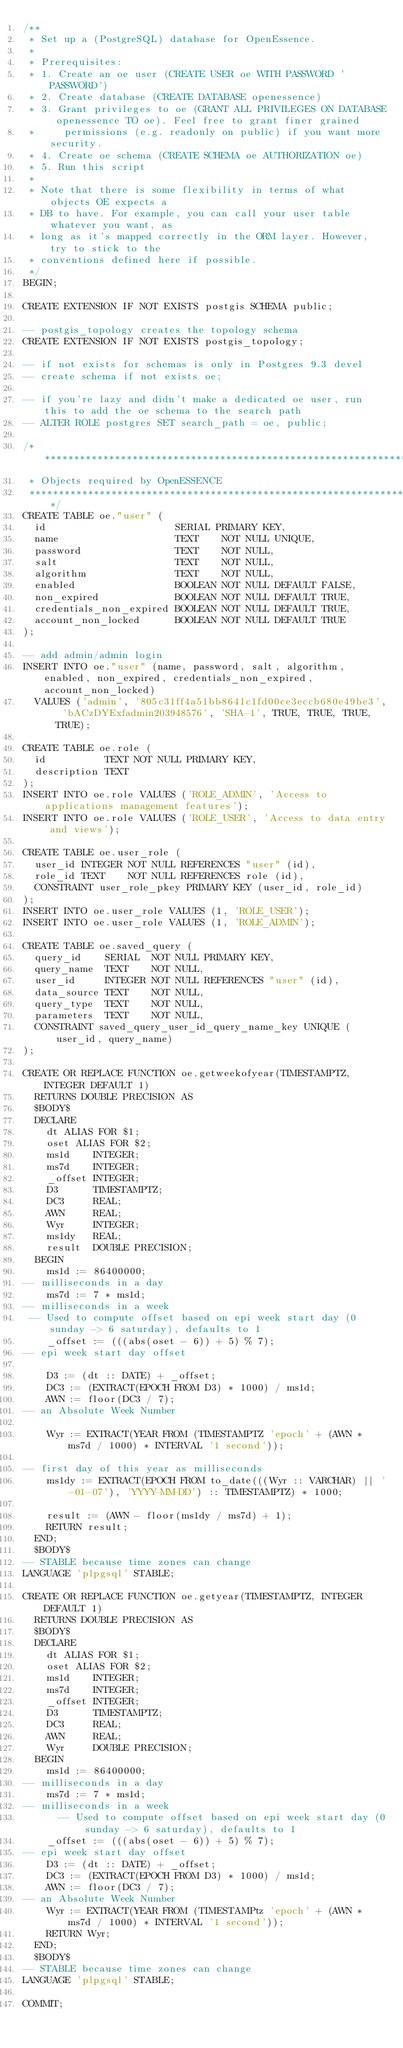<code> <loc_0><loc_0><loc_500><loc_500><_SQL_>/**
 * Set up a (PostgreSQL) database for OpenEssence.
 *
 * Prerequisites:
 * 1. Create an oe user (CREATE USER oe WITH PASSWORD 'PASSWORD')
 * 2. Create database (CREATE DATABASE openessence)
 * 3. Grant privileges to oe (GRANT ALL PRIVILEGES ON DATABASE openessence TO oe). Feel free to grant finer grained
 *     permissions (e.g. readonly on public) if you want more security.
 * 4. Create oe schema (CREATE SCHEMA oe AUTHORIZATION oe)
 * 5. Run this script
 *
 * Note that there is some flexibility in terms of what objects OE expects a
 * DB to have. For example, you can call your user table whatever you want, as
 * long as it's mapped correctly in the ORM layer. However, try to stick to the
 * conventions defined here if possible.
 */
BEGIN;

CREATE EXTENSION IF NOT EXISTS postgis SCHEMA public;

-- postgis_topology creates the topology schema
CREATE EXTENSION IF NOT EXISTS postgis_topology;

-- if not exists for schemas is only in Postgres 9.3 devel
-- create schema if not exists oe;

-- if you're lazy and didn't make a dedicated oe user, run this to add the oe schema to the search path
-- ALTER ROLE postgres SET search_path = oe, public;

/*****************************************************************************
 * Objects required by OpenESSENCE
 *****************************************************************************/
CREATE TABLE oe."user" (
  id                      SERIAL PRIMARY KEY,
  name                    TEXT    NOT NULL UNIQUE,
  password                TEXT    NOT NULL,
  salt                    TEXT    NOT NULL,
  algorithm               TEXT    NOT NULL,
  enabled                 BOOLEAN NOT NULL DEFAULT FALSE,
  non_expired             BOOLEAN NOT NULL DEFAULT TRUE,
  credentials_non_expired BOOLEAN NOT NULL DEFAULT TRUE,
  account_non_locked      BOOLEAN NOT NULL DEFAULT TRUE
);

-- add admin/admin login
INSERT INTO oe."user" (name, password, salt, algorithm, enabled, non_expired, credentials_non_expired, account_non_locked)
  VALUES ('admin', '805c31ff4a51bb8641c1fd00ce3eccb680e49be3', 'bACzDYExfadmin203948576', 'SHA-1', TRUE, TRUE, TRUE, TRUE);

CREATE TABLE oe.role (
  id          TEXT NOT NULL PRIMARY KEY,
  description TEXT
);
INSERT INTO oe.role VALUES ('ROLE_ADMIN', 'Access to applications management features');
INSERT INTO oe.role VALUES ('ROLE_USER', 'Access to data entry and views');

CREATE TABLE oe.user_role (
  user_id INTEGER NOT NULL REFERENCES "user" (id),
  role_id TEXT    NOT NULL REFERENCES role (id),
  CONSTRAINT user_role_pkey PRIMARY KEY (user_id, role_id)
);
INSERT INTO oe.user_role VALUES (1, 'ROLE_USER');
INSERT INTO oe.user_role VALUES (1, 'ROLE_ADMIN');

CREATE TABLE oe.saved_query (
  query_id    SERIAL  NOT NULL PRIMARY KEY,
  query_name  TEXT    NOT NULL,
  user_id     INTEGER NOT NULL REFERENCES "user" (id),
  data_source TEXT    NOT NULL,
  query_type  TEXT    NOT NULL,
  parameters  TEXT    NOT NULL,
  CONSTRAINT saved_query_user_id_query_name_key UNIQUE (user_id, query_name)
);

CREATE OR REPLACE FUNCTION oe.getweekofyear(TIMESTAMPTZ, INTEGER DEFAULT 1)
  RETURNS DOUBLE PRECISION AS
  $BODY$
  DECLARE
    dt ALIAS FOR $1;
    oset ALIAS FOR $2;
    ms1d    INTEGER;
    ms7d    INTEGER;
    _offset INTEGER;
    D3      TIMESTAMPTZ;
    DC3     REAL;
    AWN     REAL;
    Wyr     INTEGER;
    ms1dy   REAL;
    result  DOUBLE PRECISION;
  BEGIN
    ms1d := 86400000;
-- milliseconds in a day
    ms7d := 7 * ms1d;
-- milliseconds in a week
 -- Used to compute offset based on epi week start day (0 sunday -> 6 saturday), defaults to 1
    _offset := (((abs(oset - 6)) + 5) % 7);
-- epi week start day offset

    D3 := (dt :: DATE) + _offset;
    DC3 := (EXTRACT(EPOCH FROM D3) * 1000) / ms1d;
    AWN := floor(DC3 / 7);
-- an Absolute Week Number

    Wyr := EXTRACT(YEAR FROM (TIMESTAMPTZ 'epoch' + (AWN * ms7d / 1000) * INTERVAL '1 second'));

-- first day of this year as milliseconds
    ms1dy := EXTRACT(EPOCH FROM to_date(((Wyr :: VARCHAR) || '-01-07'), 'YYYY-MM-DD') :: TIMESTAMPTZ) * 1000;

    result := (AWN - floor(ms1dy / ms7d) + 1);
    RETURN result;
  END;
  $BODY$
-- STABLE because time zones can change
LANGUAGE 'plpgsql' STABLE;

CREATE OR REPLACE FUNCTION oe.getyear(TIMESTAMPTZ, INTEGER DEFAULT 1)
  RETURNS DOUBLE PRECISION AS
  $BODY$
  DECLARE
    dt ALIAS FOR $1;
    oset ALIAS FOR $2;
    ms1d    INTEGER;
    ms7d    INTEGER;
    _offset INTEGER;
    D3      TIMESTAMPTZ;
    DC3     REAL;
    AWN     REAL;
    Wyr     DOUBLE PRECISION;
  BEGIN
    ms1d := 86400000;
-- milliseconds in a day
    ms7d := 7 * ms1d;
-- milliseconds in a week
      -- Used to compute offset based on epi week start day (0 sunday -> 6 saturday), defaults to 1
    _offset := (((abs(oset - 6)) + 5) % 7);
-- epi week start day offset
    D3 := (dt :: DATE) + _offset;
    DC3 := (EXTRACT(EPOCH FROM D3) * 1000) / ms1d;
    AWN := floor(DC3 / 7);
-- an Absolute Week Number
    Wyr := EXTRACT(YEAR FROM (TIMESTAMPtz 'epoch' + (AWN * ms7d / 1000) * INTERVAL '1 second'));
    RETURN Wyr;
  END;
  $BODY$
-- STABLE because time zones can change
LANGUAGE 'plpgsql' STABLE;

COMMIT;
</code> 